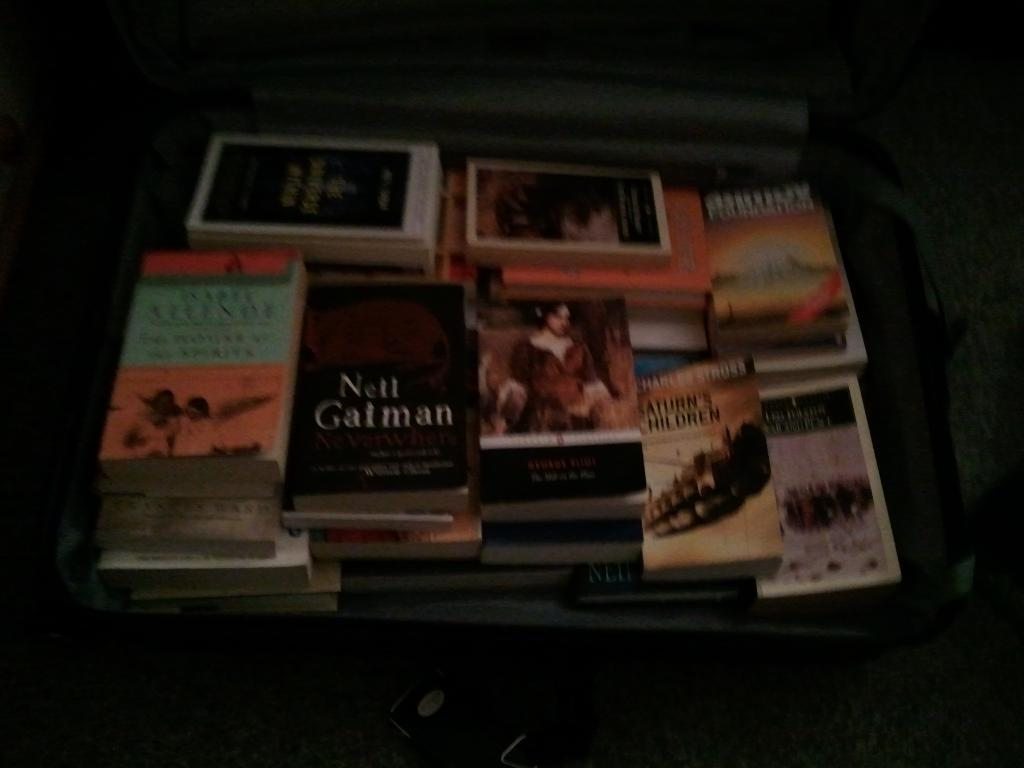What objects are inside the suitcase in the image? There are books in a suitcase in the image. Where is the suitcase located? The suitcase is placed on a platform. What can be observed about the lighting in the image? The background of the image is dark. What type of pickle is being used in the image? There is no pickle present in the image. 